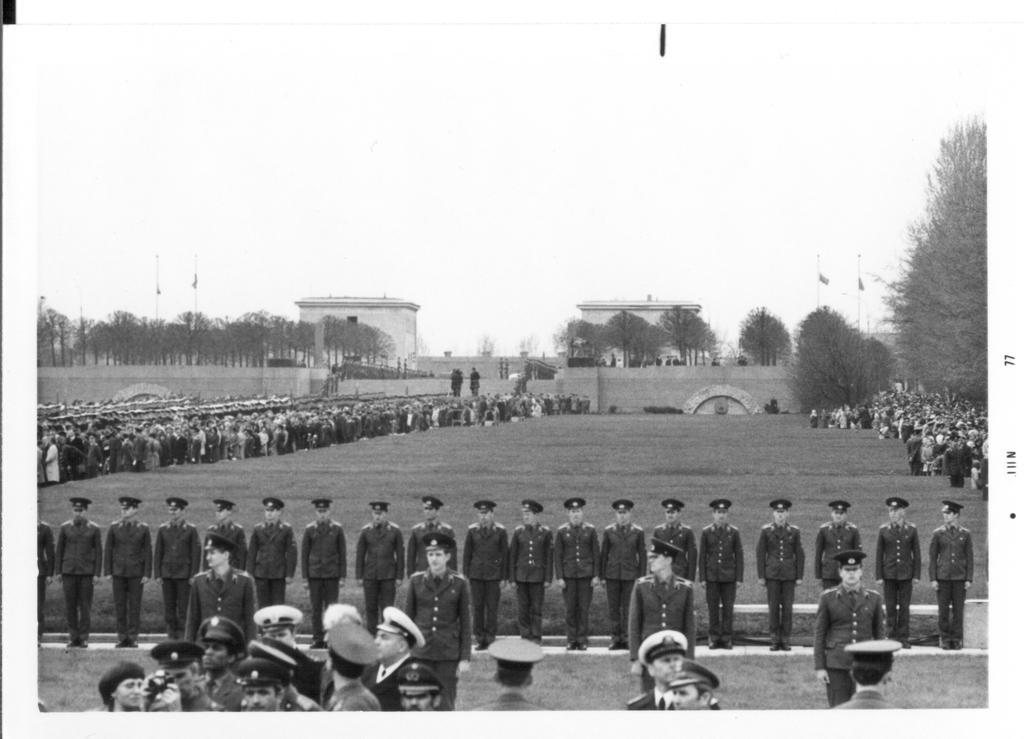Can you describe this image briefly? This is a black and white pic. At the bottom there are few persons standing and all of them have caps on their heads. In the background on the left and right side we can see many people are standing and in the middle we can see grass on the ground, trees, buildings, poles, flags and sky. 